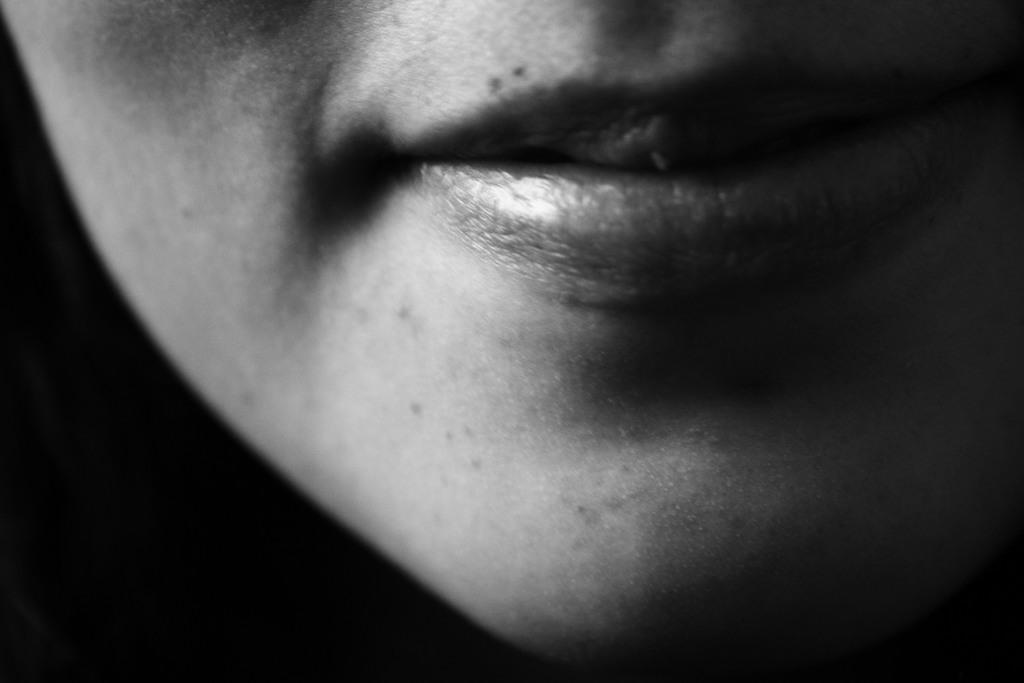Describe this image in one or two sentences. In this image I can see mouth of a person. I can also see this image is black and white in colour. 